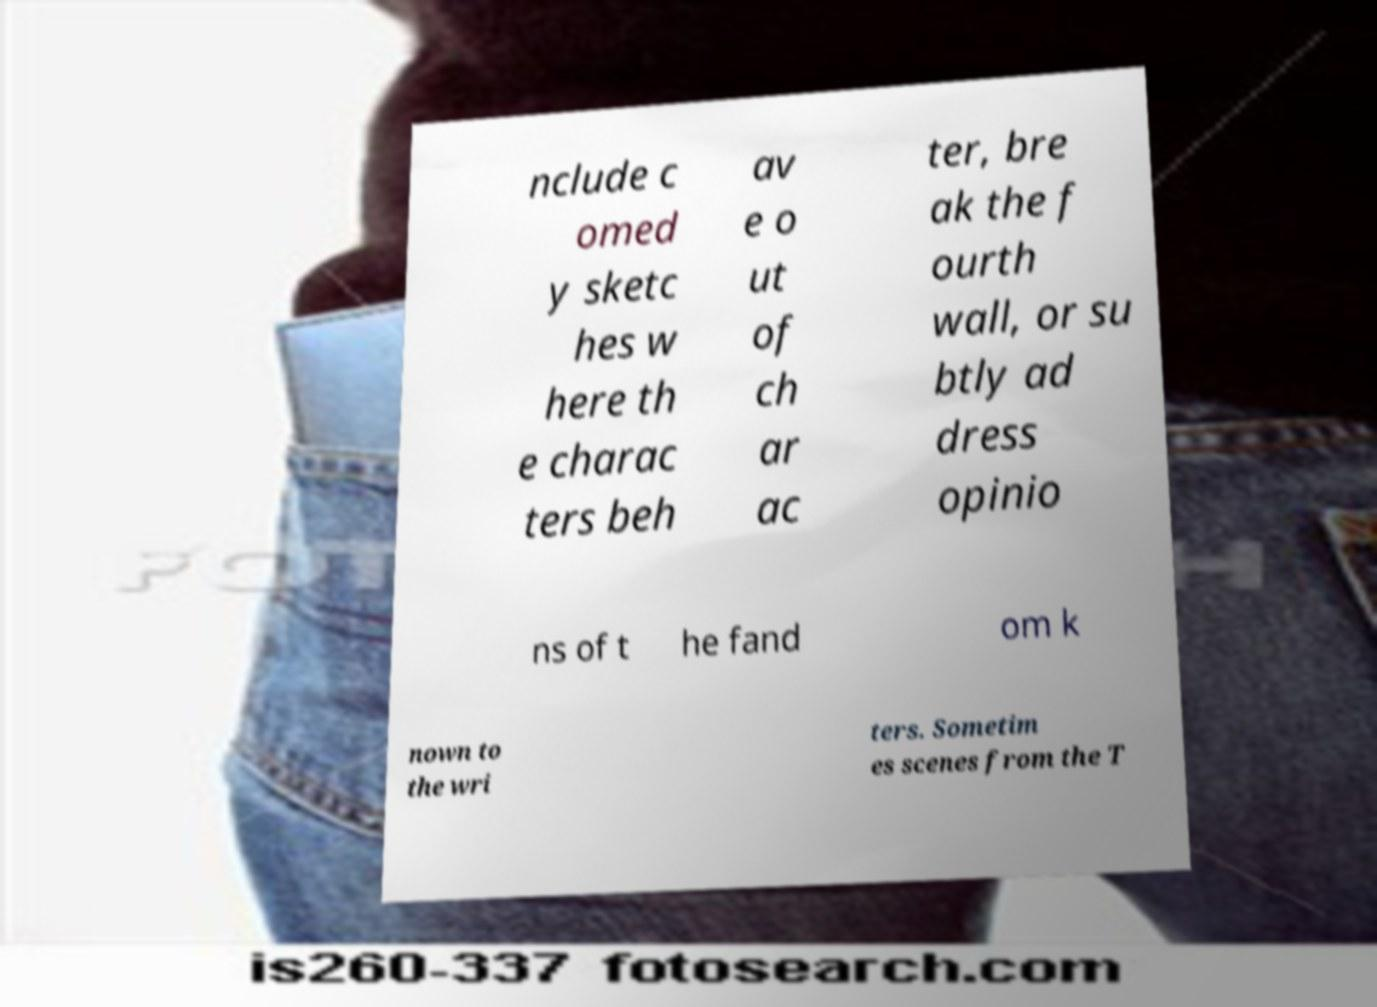What messages or text are displayed in this image? I need them in a readable, typed format. nclude c omed y sketc hes w here th e charac ters beh av e o ut of ch ar ac ter, bre ak the f ourth wall, or su btly ad dress opinio ns of t he fand om k nown to the wri ters. Sometim es scenes from the T 